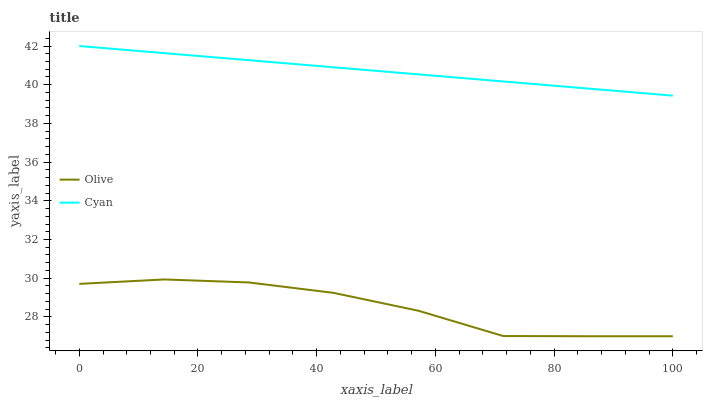Does Olive have the minimum area under the curve?
Answer yes or no. Yes. Does Cyan have the maximum area under the curve?
Answer yes or no. Yes. Does Cyan have the minimum area under the curve?
Answer yes or no. No. Is Cyan the smoothest?
Answer yes or no. Yes. Is Olive the roughest?
Answer yes or no. Yes. Is Cyan the roughest?
Answer yes or no. No. Does Olive have the lowest value?
Answer yes or no. Yes. Does Cyan have the lowest value?
Answer yes or no. No. Does Cyan have the highest value?
Answer yes or no. Yes. Is Olive less than Cyan?
Answer yes or no. Yes. Is Cyan greater than Olive?
Answer yes or no. Yes. Does Olive intersect Cyan?
Answer yes or no. No. 